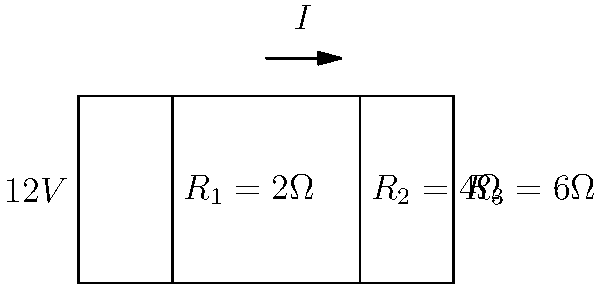In this series circuit representing the "Swift Boat Veterans for Truth" controversy, we have three resistors symbolizing challenges faced by John Kerry's campaign. Given a voltage source of 12V and resistances $R_1 = 2\Omega$, $R_2 = 4\Omega$, and $R_3 = 6\Omega$, what is the voltage drop across $R_2$? To solve this problem, we'll follow these steps:

1) First, calculate the total resistance of the circuit:
   $R_{total} = R_1 + R_2 + R_3 = 2\Omega + 4\Omega + 6\Omega = 12\Omega$

2) Use Ohm's Law to find the current in the circuit:
   $I = \frac{V}{R_{total}} = \frac{12V}{12\Omega} = 1A$

3) The voltage drop across $R_2$ can be calculated using Ohm's Law:
   $V_{R2} = I \times R_2 = 1A \times 4\Omega = 4V$

This 4V drop across $R_2$ could symbolize the impact of the "Swift Boat" ads on Kerry's campaign, representing a significant challenge but not an insurmountable one in the context of the entire race.
Answer: $4V$ 